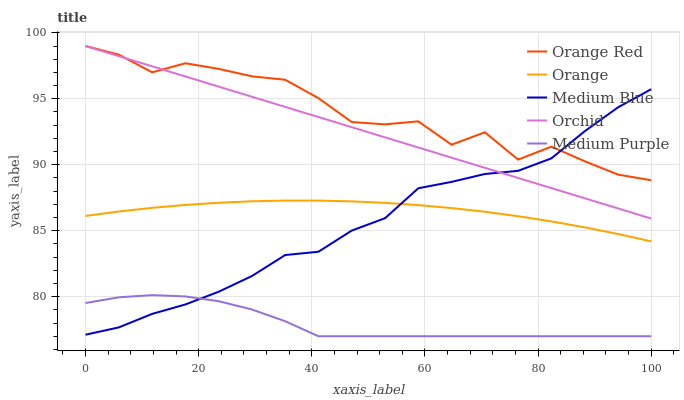Does Medium Blue have the minimum area under the curve?
Answer yes or no. No. Does Medium Blue have the maximum area under the curve?
Answer yes or no. No. Is Medium Purple the smoothest?
Answer yes or no. No. Is Medium Purple the roughest?
Answer yes or no. No. Does Medium Blue have the lowest value?
Answer yes or no. No. Does Medium Blue have the highest value?
Answer yes or no. No. Is Medium Purple less than Orange Red?
Answer yes or no. Yes. Is Orchid greater than Medium Purple?
Answer yes or no. Yes. Does Medium Purple intersect Orange Red?
Answer yes or no. No. 